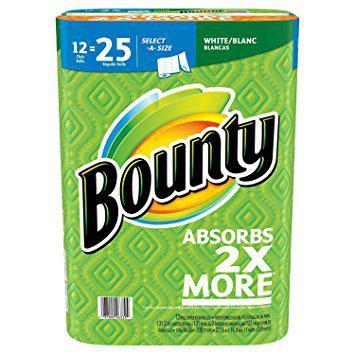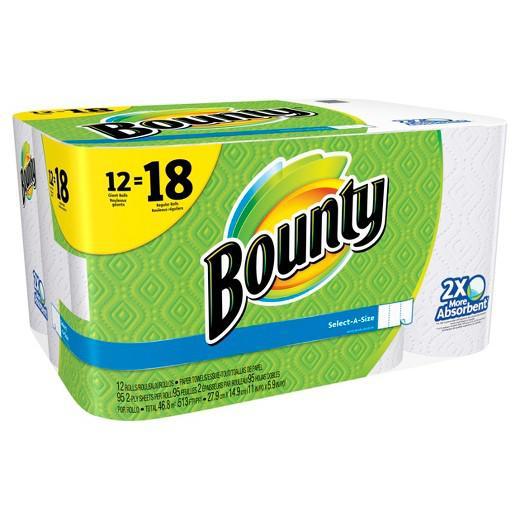The first image is the image on the left, the second image is the image on the right. Considering the images on both sides, is "The color scheme on the paper towel products on the left and right is primarily green, and each image contains exactly one multipack of paper towels." valid? Answer yes or no. Yes. The first image is the image on the left, the second image is the image on the right. Given the left and right images, does the statement "There are more than thirteen rolls." hold true? Answer yes or no. Yes. 